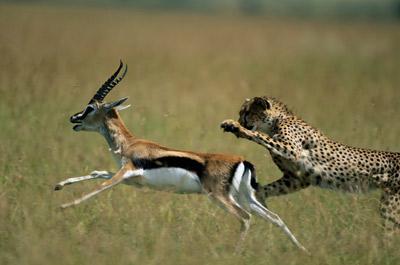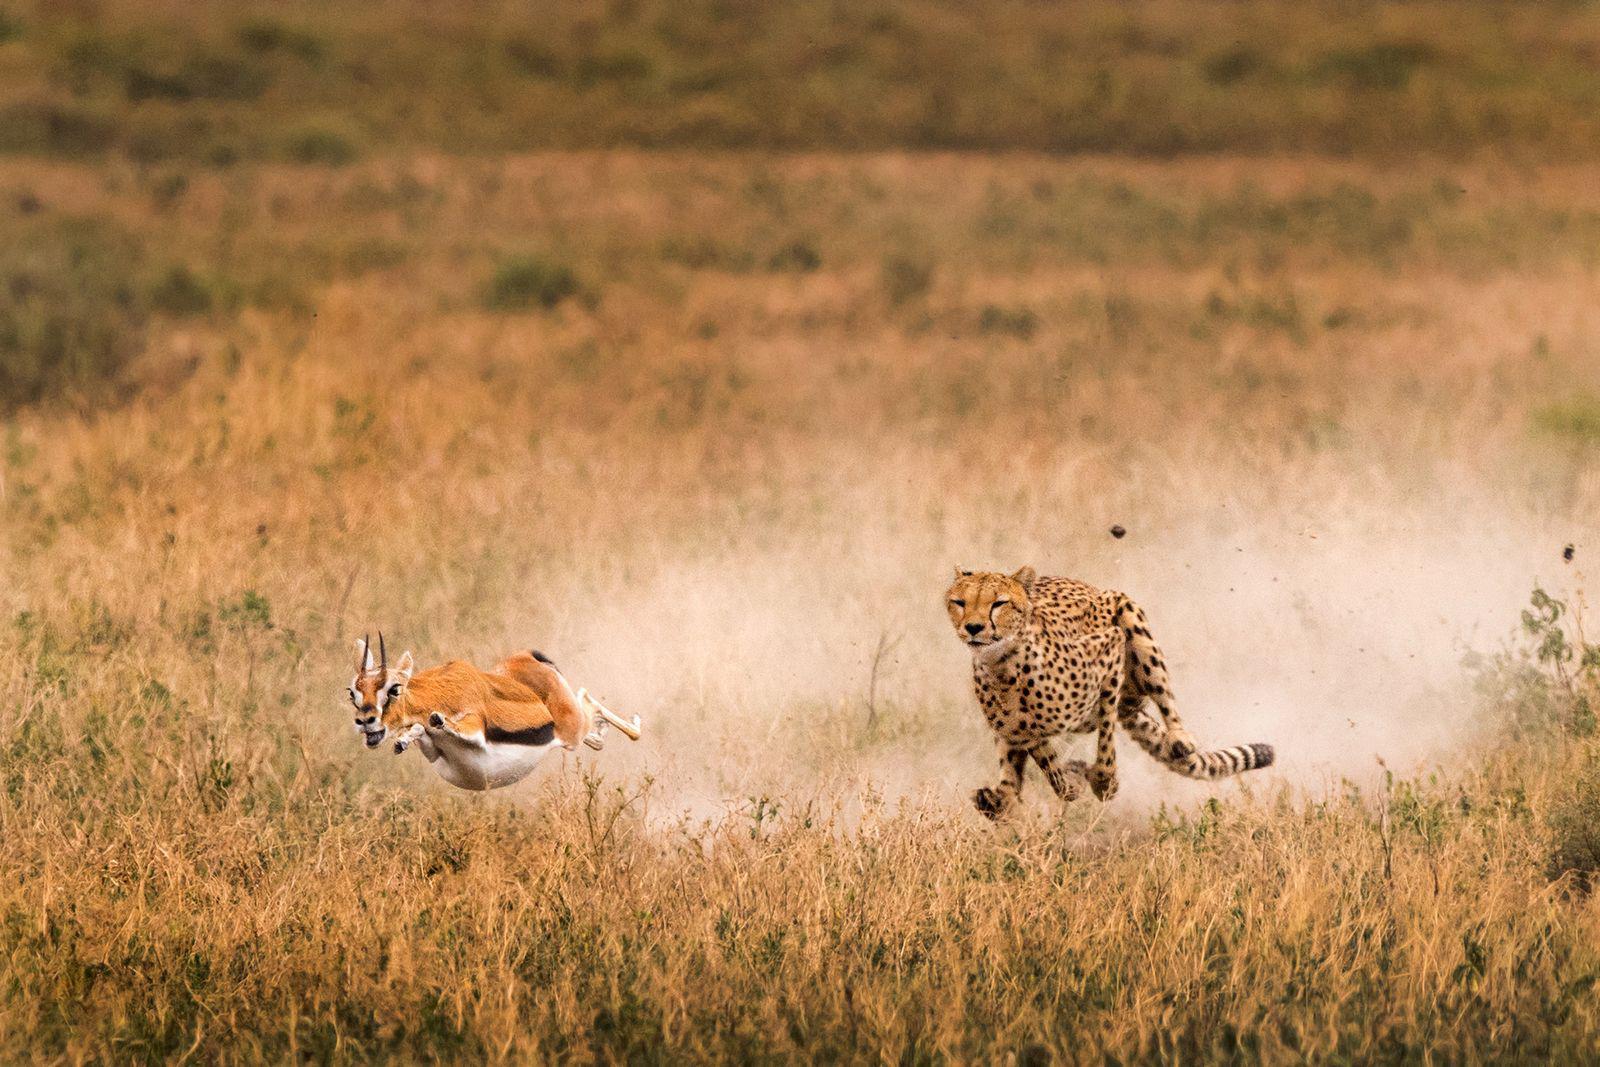The first image is the image on the left, the second image is the image on the right. Analyze the images presented: Is the assertion "In one image, a cheetah is about to capture a hooved animal as the cat strikes from behind the leftward-moving prey." valid? Answer yes or no. Yes. 